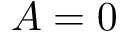Convert formula to latex. <formula><loc_0><loc_0><loc_500><loc_500>A = 0</formula> 